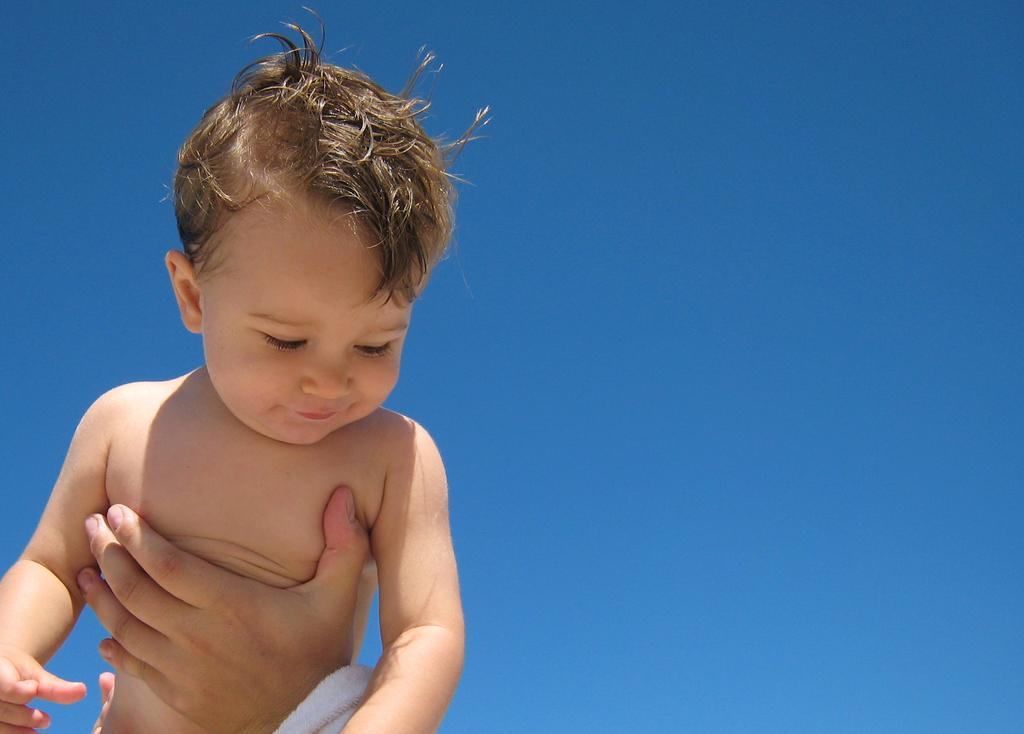What part of a person can be seen in the image? There is a person's hand in the image. Who else is present in the image besides the person's hand? There is a kid in the image. What can be seen in the background of the image? The sky is visible in the background of the image. What type of square can be seen in the image? There is no square present in the image. Can you describe the man in the image? There is no man present in the image; only a person's hand and a kid can be seen. 